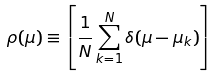<formula> <loc_0><loc_0><loc_500><loc_500>\rho ( \mu ) \equiv \left [ \frac { 1 } { N } \sum _ { k = 1 } ^ { N } \delta ( \mu - \mu _ { k } ) \right ]</formula> 